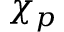<formula> <loc_0><loc_0><loc_500><loc_500>\chi _ { p }</formula> 